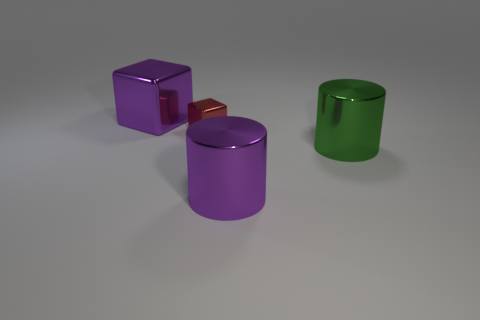Add 2 red metal cubes. How many objects exist? 6 Subtract 0 green cubes. How many objects are left? 4 Subtract all small objects. Subtract all large green metal things. How many objects are left? 2 Add 4 tiny metallic things. How many tiny metallic things are left? 5 Add 3 large purple shiny cubes. How many large purple shiny cubes exist? 4 